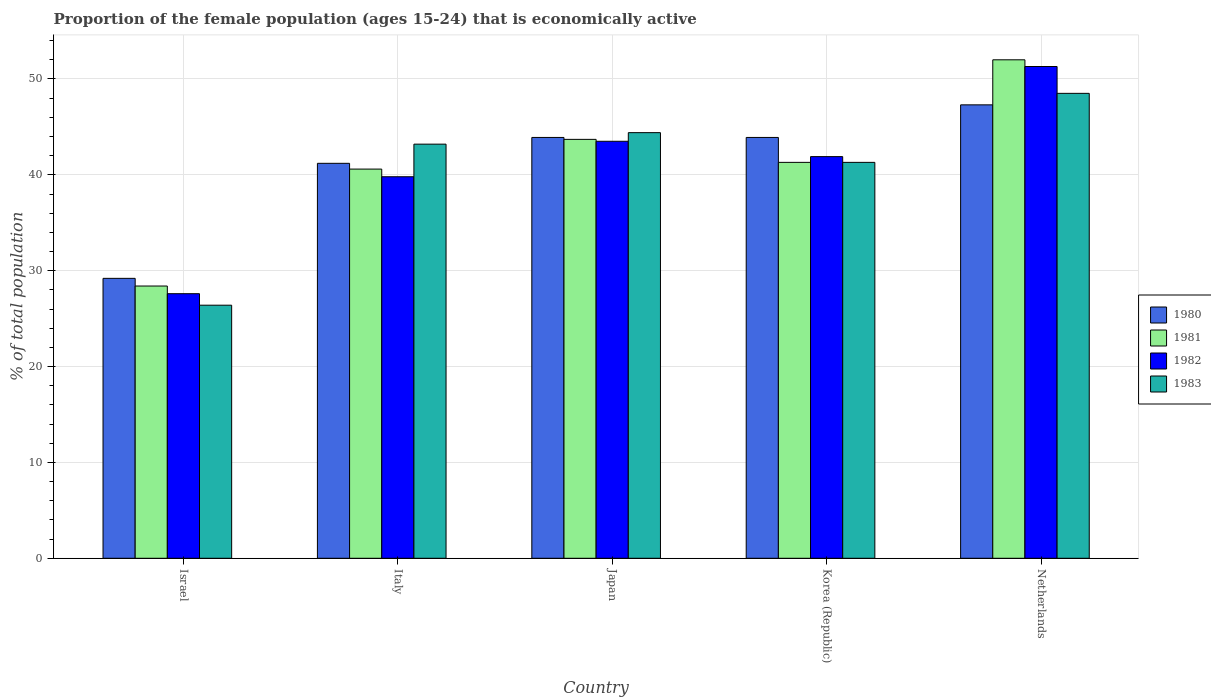How many groups of bars are there?
Your response must be concise. 5. Are the number of bars on each tick of the X-axis equal?
Make the answer very short. Yes. What is the label of the 3rd group of bars from the left?
Your answer should be compact. Japan. What is the proportion of the female population that is economically active in 1983 in Japan?
Provide a short and direct response. 44.4. Across all countries, what is the maximum proportion of the female population that is economically active in 1983?
Give a very brief answer. 48.5. Across all countries, what is the minimum proportion of the female population that is economically active in 1980?
Offer a terse response. 29.2. What is the total proportion of the female population that is economically active in 1980 in the graph?
Ensure brevity in your answer.  205.5. What is the difference between the proportion of the female population that is economically active in 1980 in Italy and that in Korea (Republic)?
Provide a succinct answer. -2.7. What is the difference between the proportion of the female population that is economically active in 1981 in Netherlands and the proportion of the female population that is economically active in 1982 in Israel?
Give a very brief answer. 24.4. What is the average proportion of the female population that is economically active in 1980 per country?
Keep it short and to the point. 41.1. What is the difference between the proportion of the female population that is economically active of/in 1982 and proportion of the female population that is economically active of/in 1980 in Japan?
Ensure brevity in your answer.  -0.4. In how many countries, is the proportion of the female population that is economically active in 1982 greater than 8 %?
Provide a short and direct response. 5. What is the ratio of the proportion of the female population that is economically active in 1982 in Italy to that in Japan?
Offer a very short reply. 0.91. Is the proportion of the female population that is economically active in 1983 in Israel less than that in Italy?
Your answer should be very brief. Yes. What is the difference between the highest and the second highest proportion of the female population that is economically active in 1983?
Make the answer very short. 5.3. What is the difference between the highest and the lowest proportion of the female population that is economically active in 1982?
Provide a short and direct response. 23.7. In how many countries, is the proportion of the female population that is economically active in 1980 greater than the average proportion of the female population that is economically active in 1980 taken over all countries?
Your answer should be compact. 4. Is it the case that in every country, the sum of the proportion of the female population that is economically active in 1983 and proportion of the female population that is economically active in 1980 is greater than the sum of proportion of the female population that is economically active in 1982 and proportion of the female population that is economically active in 1981?
Provide a succinct answer. No. Is it the case that in every country, the sum of the proportion of the female population that is economically active in 1980 and proportion of the female population that is economically active in 1982 is greater than the proportion of the female population that is economically active in 1983?
Make the answer very short. Yes. Are all the bars in the graph horizontal?
Give a very brief answer. No. Are the values on the major ticks of Y-axis written in scientific E-notation?
Provide a short and direct response. No. Does the graph contain grids?
Give a very brief answer. Yes. What is the title of the graph?
Provide a succinct answer. Proportion of the female population (ages 15-24) that is economically active. What is the label or title of the Y-axis?
Offer a terse response. % of total population. What is the % of total population of 1980 in Israel?
Your answer should be compact. 29.2. What is the % of total population of 1981 in Israel?
Give a very brief answer. 28.4. What is the % of total population of 1982 in Israel?
Provide a succinct answer. 27.6. What is the % of total population of 1983 in Israel?
Your response must be concise. 26.4. What is the % of total population in 1980 in Italy?
Your answer should be compact. 41.2. What is the % of total population in 1981 in Italy?
Give a very brief answer. 40.6. What is the % of total population of 1982 in Italy?
Give a very brief answer. 39.8. What is the % of total population in 1983 in Italy?
Make the answer very short. 43.2. What is the % of total population in 1980 in Japan?
Provide a short and direct response. 43.9. What is the % of total population in 1981 in Japan?
Your answer should be compact. 43.7. What is the % of total population of 1982 in Japan?
Make the answer very short. 43.5. What is the % of total population in 1983 in Japan?
Your answer should be very brief. 44.4. What is the % of total population of 1980 in Korea (Republic)?
Keep it short and to the point. 43.9. What is the % of total population in 1981 in Korea (Republic)?
Offer a very short reply. 41.3. What is the % of total population of 1982 in Korea (Republic)?
Offer a very short reply. 41.9. What is the % of total population of 1983 in Korea (Republic)?
Provide a short and direct response. 41.3. What is the % of total population of 1980 in Netherlands?
Your answer should be very brief. 47.3. What is the % of total population of 1982 in Netherlands?
Keep it short and to the point. 51.3. What is the % of total population in 1983 in Netherlands?
Ensure brevity in your answer.  48.5. Across all countries, what is the maximum % of total population in 1980?
Your response must be concise. 47.3. Across all countries, what is the maximum % of total population of 1982?
Give a very brief answer. 51.3. Across all countries, what is the maximum % of total population of 1983?
Keep it short and to the point. 48.5. Across all countries, what is the minimum % of total population of 1980?
Offer a very short reply. 29.2. Across all countries, what is the minimum % of total population of 1981?
Your answer should be compact. 28.4. Across all countries, what is the minimum % of total population of 1982?
Offer a very short reply. 27.6. Across all countries, what is the minimum % of total population of 1983?
Ensure brevity in your answer.  26.4. What is the total % of total population in 1980 in the graph?
Your answer should be compact. 205.5. What is the total % of total population in 1981 in the graph?
Ensure brevity in your answer.  206. What is the total % of total population of 1982 in the graph?
Your answer should be very brief. 204.1. What is the total % of total population in 1983 in the graph?
Your answer should be very brief. 203.8. What is the difference between the % of total population of 1980 in Israel and that in Italy?
Offer a terse response. -12. What is the difference between the % of total population in 1981 in Israel and that in Italy?
Provide a succinct answer. -12.2. What is the difference between the % of total population in 1982 in Israel and that in Italy?
Offer a very short reply. -12.2. What is the difference between the % of total population in 1983 in Israel and that in Italy?
Offer a terse response. -16.8. What is the difference between the % of total population in 1980 in Israel and that in Japan?
Keep it short and to the point. -14.7. What is the difference between the % of total population of 1981 in Israel and that in Japan?
Give a very brief answer. -15.3. What is the difference between the % of total population of 1982 in Israel and that in Japan?
Offer a terse response. -15.9. What is the difference between the % of total population in 1983 in Israel and that in Japan?
Give a very brief answer. -18. What is the difference between the % of total population in 1980 in Israel and that in Korea (Republic)?
Offer a very short reply. -14.7. What is the difference between the % of total population in 1982 in Israel and that in Korea (Republic)?
Your answer should be very brief. -14.3. What is the difference between the % of total population of 1983 in Israel and that in Korea (Republic)?
Your answer should be compact. -14.9. What is the difference between the % of total population in 1980 in Israel and that in Netherlands?
Make the answer very short. -18.1. What is the difference between the % of total population of 1981 in Israel and that in Netherlands?
Your answer should be compact. -23.6. What is the difference between the % of total population in 1982 in Israel and that in Netherlands?
Ensure brevity in your answer.  -23.7. What is the difference between the % of total population of 1983 in Israel and that in Netherlands?
Ensure brevity in your answer.  -22.1. What is the difference between the % of total population of 1980 in Italy and that in Japan?
Offer a very short reply. -2.7. What is the difference between the % of total population in 1981 in Italy and that in Japan?
Your response must be concise. -3.1. What is the difference between the % of total population in 1982 in Italy and that in Korea (Republic)?
Give a very brief answer. -2.1. What is the difference between the % of total population in 1981 in Italy and that in Netherlands?
Make the answer very short. -11.4. What is the difference between the % of total population of 1983 in Italy and that in Netherlands?
Your answer should be compact. -5.3. What is the difference between the % of total population in 1981 in Japan and that in Korea (Republic)?
Provide a succinct answer. 2.4. What is the difference between the % of total population of 1981 in Japan and that in Netherlands?
Make the answer very short. -8.3. What is the difference between the % of total population of 1983 in Japan and that in Netherlands?
Offer a very short reply. -4.1. What is the difference between the % of total population of 1981 in Korea (Republic) and that in Netherlands?
Ensure brevity in your answer.  -10.7. What is the difference between the % of total population of 1983 in Korea (Republic) and that in Netherlands?
Provide a short and direct response. -7.2. What is the difference between the % of total population in 1981 in Israel and the % of total population in 1983 in Italy?
Your answer should be very brief. -14.8. What is the difference between the % of total population of 1982 in Israel and the % of total population of 1983 in Italy?
Your answer should be compact. -15.6. What is the difference between the % of total population of 1980 in Israel and the % of total population of 1981 in Japan?
Offer a very short reply. -14.5. What is the difference between the % of total population in 1980 in Israel and the % of total population in 1982 in Japan?
Make the answer very short. -14.3. What is the difference between the % of total population in 1980 in Israel and the % of total population in 1983 in Japan?
Give a very brief answer. -15.2. What is the difference between the % of total population in 1981 in Israel and the % of total population in 1982 in Japan?
Your response must be concise. -15.1. What is the difference between the % of total population in 1981 in Israel and the % of total population in 1983 in Japan?
Offer a terse response. -16. What is the difference between the % of total population in 1982 in Israel and the % of total population in 1983 in Japan?
Your response must be concise. -16.8. What is the difference between the % of total population of 1980 in Israel and the % of total population of 1981 in Korea (Republic)?
Keep it short and to the point. -12.1. What is the difference between the % of total population in 1982 in Israel and the % of total population in 1983 in Korea (Republic)?
Ensure brevity in your answer.  -13.7. What is the difference between the % of total population of 1980 in Israel and the % of total population of 1981 in Netherlands?
Provide a short and direct response. -22.8. What is the difference between the % of total population of 1980 in Israel and the % of total population of 1982 in Netherlands?
Keep it short and to the point. -22.1. What is the difference between the % of total population of 1980 in Israel and the % of total population of 1983 in Netherlands?
Make the answer very short. -19.3. What is the difference between the % of total population in 1981 in Israel and the % of total population in 1982 in Netherlands?
Your answer should be compact. -22.9. What is the difference between the % of total population in 1981 in Israel and the % of total population in 1983 in Netherlands?
Provide a short and direct response. -20.1. What is the difference between the % of total population of 1982 in Israel and the % of total population of 1983 in Netherlands?
Provide a short and direct response. -20.9. What is the difference between the % of total population in 1980 in Italy and the % of total population in 1982 in Japan?
Your answer should be compact. -2.3. What is the difference between the % of total population of 1980 in Italy and the % of total population of 1983 in Japan?
Give a very brief answer. -3.2. What is the difference between the % of total population of 1982 in Italy and the % of total population of 1983 in Japan?
Provide a succinct answer. -4.6. What is the difference between the % of total population of 1980 in Italy and the % of total population of 1982 in Korea (Republic)?
Give a very brief answer. -0.7. What is the difference between the % of total population of 1982 in Italy and the % of total population of 1983 in Korea (Republic)?
Your answer should be compact. -1.5. What is the difference between the % of total population in 1980 in Italy and the % of total population in 1982 in Netherlands?
Your response must be concise. -10.1. What is the difference between the % of total population of 1980 in Italy and the % of total population of 1983 in Netherlands?
Keep it short and to the point. -7.3. What is the difference between the % of total population of 1982 in Italy and the % of total population of 1983 in Netherlands?
Offer a very short reply. -8.7. What is the difference between the % of total population of 1980 in Japan and the % of total population of 1981 in Korea (Republic)?
Offer a terse response. 2.6. What is the difference between the % of total population in 1980 in Japan and the % of total population in 1983 in Korea (Republic)?
Provide a short and direct response. 2.6. What is the difference between the % of total population in 1980 in Korea (Republic) and the % of total population in 1983 in Netherlands?
Your answer should be compact. -4.6. What is the difference between the % of total population in 1981 in Korea (Republic) and the % of total population in 1983 in Netherlands?
Keep it short and to the point. -7.2. What is the average % of total population of 1980 per country?
Offer a very short reply. 41.1. What is the average % of total population of 1981 per country?
Ensure brevity in your answer.  41.2. What is the average % of total population of 1982 per country?
Your answer should be very brief. 40.82. What is the average % of total population of 1983 per country?
Offer a terse response. 40.76. What is the difference between the % of total population in 1980 and % of total population in 1981 in Israel?
Provide a short and direct response. 0.8. What is the difference between the % of total population in 1980 and % of total population in 1983 in Israel?
Your answer should be very brief. 2.8. What is the difference between the % of total population in 1981 and % of total population in 1983 in Israel?
Your response must be concise. 2. What is the difference between the % of total population in 1980 and % of total population in 1982 in Italy?
Give a very brief answer. 1.4. What is the difference between the % of total population of 1981 and % of total population of 1982 in Italy?
Your answer should be very brief. 0.8. What is the difference between the % of total population in 1982 and % of total population in 1983 in Italy?
Provide a short and direct response. -3.4. What is the difference between the % of total population of 1981 and % of total population of 1983 in Korea (Republic)?
Provide a succinct answer. 0. What is the difference between the % of total population of 1982 and % of total population of 1983 in Korea (Republic)?
Offer a very short reply. 0.6. What is the difference between the % of total population of 1980 and % of total population of 1981 in Netherlands?
Your answer should be very brief. -4.7. What is the difference between the % of total population of 1980 and % of total population of 1982 in Netherlands?
Give a very brief answer. -4. What is the difference between the % of total population of 1980 and % of total population of 1983 in Netherlands?
Your answer should be very brief. -1.2. What is the difference between the % of total population in 1981 and % of total population in 1982 in Netherlands?
Provide a short and direct response. 0.7. What is the difference between the % of total population in 1981 and % of total population in 1983 in Netherlands?
Your answer should be compact. 3.5. What is the ratio of the % of total population of 1980 in Israel to that in Italy?
Your answer should be compact. 0.71. What is the ratio of the % of total population in 1981 in Israel to that in Italy?
Your answer should be compact. 0.7. What is the ratio of the % of total population of 1982 in Israel to that in Italy?
Give a very brief answer. 0.69. What is the ratio of the % of total population of 1983 in Israel to that in Italy?
Provide a short and direct response. 0.61. What is the ratio of the % of total population of 1980 in Israel to that in Japan?
Keep it short and to the point. 0.67. What is the ratio of the % of total population in 1981 in Israel to that in Japan?
Offer a terse response. 0.65. What is the ratio of the % of total population in 1982 in Israel to that in Japan?
Provide a succinct answer. 0.63. What is the ratio of the % of total population in 1983 in Israel to that in Japan?
Offer a terse response. 0.59. What is the ratio of the % of total population of 1980 in Israel to that in Korea (Republic)?
Provide a succinct answer. 0.67. What is the ratio of the % of total population in 1981 in Israel to that in Korea (Republic)?
Your answer should be compact. 0.69. What is the ratio of the % of total population in 1982 in Israel to that in Korea (Republic)?
Your answer should be very brief. 0.66. What is the ratio of the % of total population in 1983 in Israel to that in Korea (Republic)?
Offer a very short reply. 0.64. What is the ratio of the % of total population in 1980 in Israel to that in Netherlands?
Offer a terse response. 0.62. What is the ratio of the % of total population of 1981 in Israel to that in Netherlands?
Offer a very short reply. 0.55. What is the ratio of the % of total population of 1982 in Israel to that in Netherlands?
Offer a terse response. 0.54. What is the ratio of the % of total population of 1983 in Israel to that in Netherlands?
Make the answer very short. 0.54. What is the ratio of the % of total population in 1980 in Italy to that in Japan?
Provide a short and direct response. 0.94. What is the ratio of the % of total population in 1981 in Italy to that in Japan?
Keep it short and to the point. 0.93. What is the ratio of the % of total population of 1982 in Italy to that in Japan?
Provide a succinct answer. 0.91. What is the ratio of the % of total population in 1983 in Italy to that in Japan?
Make the answer very short. 0.97. What is the ratio of the % of total population of 1980 in Italy to that in Korea (Republic)?
Make the answer very short. 0.94. What is the ratio of the % of total population in 1981 in Italy to that in Korea (Republic)?
Ensure brevity in your answer.  0.98. What is the ratio of the % of total population in 1982 in Italy to that in Korea (Republic)?
Your response must be concise. 0.95. What is the ratio of the % of total population of 1983 in Italy to that in Korea (Republic)?
Provide a short and direct response. 1.05. What is the ratio of the % of total population of 1980 in Italy to that in Netherlands?
Your response must be concise. 0.87. What is the ratio of the % of total population in 1981 in Italy to that in Netherlands?
Your answer should be compact. 0.78. What is the ratio of the % of total population of 1982 in Italy to that in Netherlands?
Your answer should be very brief. 0.78. What is the ratio of the % of total population in 1983 in Italy to that in Netherlands?
Offer a very short reply. 0.89. What is the ratio of the % of total population in 1980 in Japan to that in Korea (Republic)?
Ensure brevity in your answer.  1. What is the ratio of the % of total population of 1981 in Japan to that in Korea (Republic)?
Make the answer very short. 1.06. What is the ratio of the % of total population of 1982 in Japan to that in Korea (Republic)?
Ensure brevity in your answer.  1.04. What is the ratio of the % of total population of 1983 in Japan to that in Korea (Republic)?
Provide a short and direct response. 1.08. What is the ratio of the % of total population of 1980 in Japan to that in Netherlands?
Give a very brief answer. 0.93. What is the ratio of the % of total population of 1981 in Japan to that in Netherlands?
Your response must be concise. 0.84. What is the ratio of the % of total population in 1982 in Japan to that in Netherlands?
Provide a succinct answer. 0.85. What is the ratio of the % of total population of 1983 in Japan to that in Netherlands?
Provide a succinct answer. 0.92. What is the ratio of the % of total population in 1980 in Korea (Republic) to that in Netherlands?
Keep it short and to the point. 0.93. What is the ratio of the % of total population in 1981 in Korea (Republic) to that in Netherlands?
Keep it short and to the point. 0.79. What is the ratio of the % of total population in 1982 in Korea (Republic) to that in Netherlands?
Give a very brief answer. 0.82. What is the ratio of the % of total population in 1983 in Korea (Republic) to that in Netherlands?
Offer a very short reply. 0.85. What is the difference between the highest and the second highest % of total population of 1981?
Give a very brief answer. 8.3. What is the difference between the highest and the second highest % of total population of 1982?
Make the answer very short. 7.8. What is the difference between the highest and the lowest % of total population in 1981?
Keep it short and to the point. 23.6. What is the difference between the highest and the lowest % of total population in 1982?
Your answer should be compact. 23.7. What is the difference between the highest and the lowest % of total population of 1983?
Ensure brevity in your answer.  22.1. 